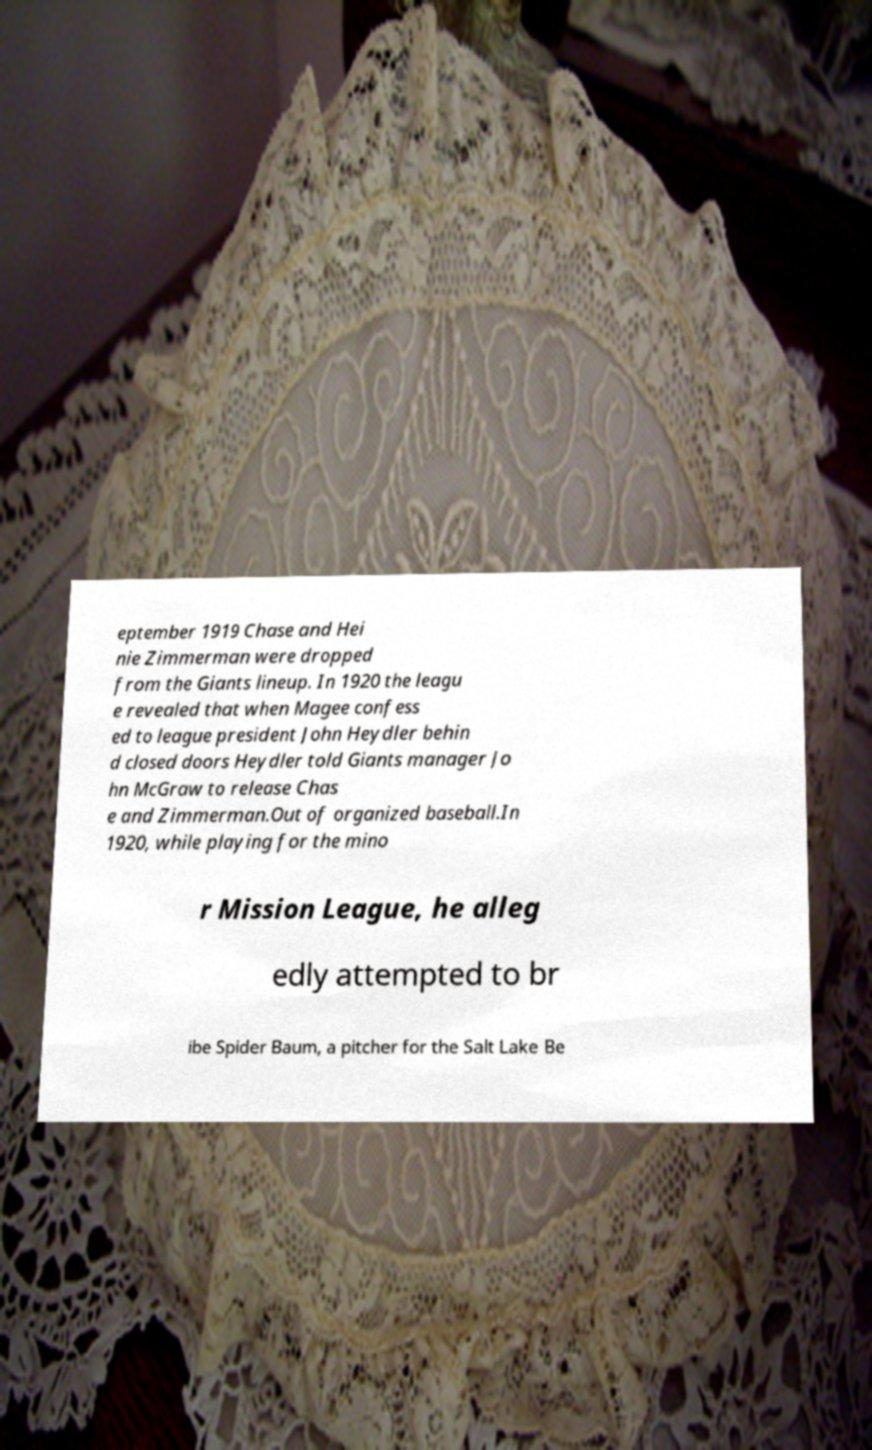Please identify and transcribe the text found in this image. eptember 1919 Chase and Hei nie Zimmerman were dropped from the Giants lineup. In 1920 the leagu e revealed that when Magee confess ed to league president John Heydler behin d closed doors Heydler told Giants manager Jo hn McGraw to release Chas e and Zimmerman.Out of organized baseball.In 1920, while playing for the mino r Mission League, he alleg edly attempted to br ibe Spider Baum, a pitcher for the Salt Lake Be 